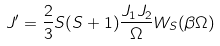Convert formula to latex. <formula><loc_0><loc_0><loc_500><loc_500>J ^ { \prime } = \frac { 2 } { 3 } S ( S + 1 ) \frac { J _ { 1 } J _ { 2 } } { \Omega } W _ { S } ( \beta \Omega )</formula> 